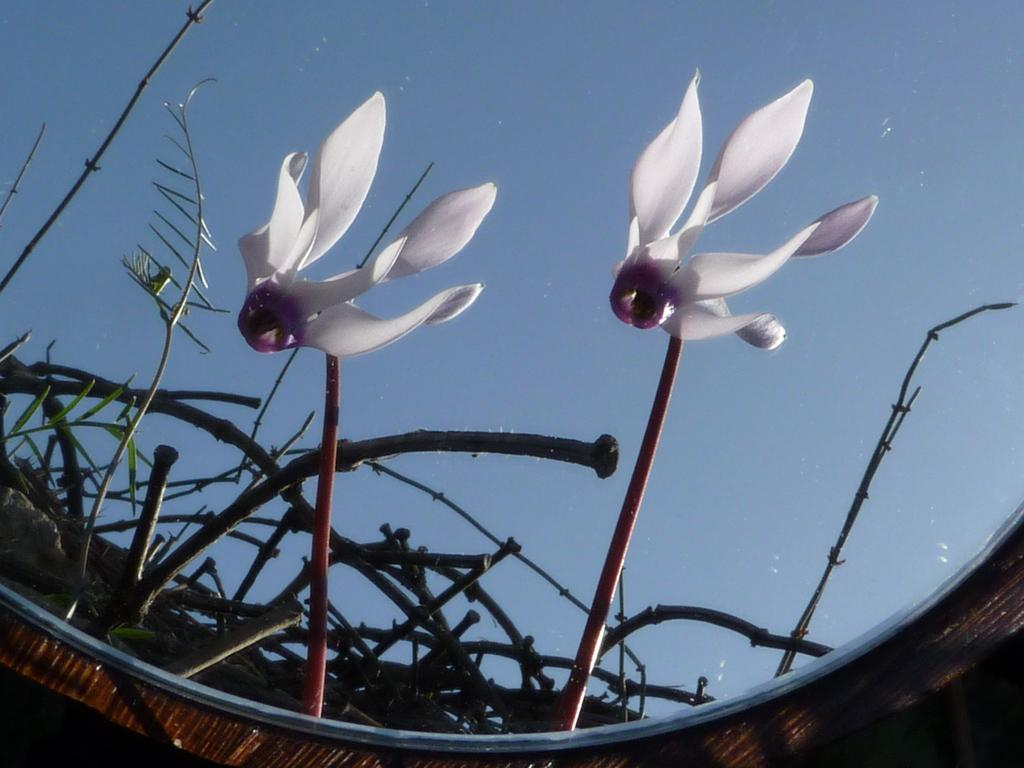What object is present in the image that reflects other objects? There is a mirror in the image. What can be seen through the mirror in the image? Plants, flowers, and the sky are visible through the mirror in the image. How many chickens are visible through the mirror in the image? There are no chickens visible through the mirror in the image. What type of knot is used to secure the plants in the image? There is no knot present in the image, as it only features a mirror reflecting plants, flowers, and the sky. 